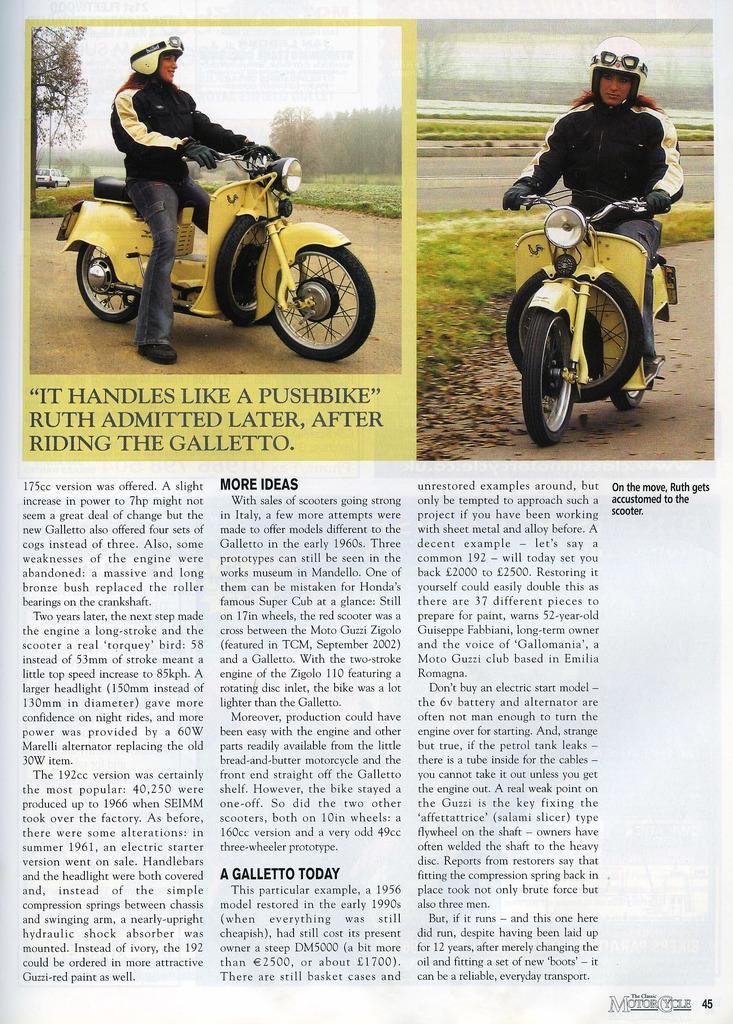Describe this image in one or two sentences. In this image i can see a newspaper on which it is written something. 